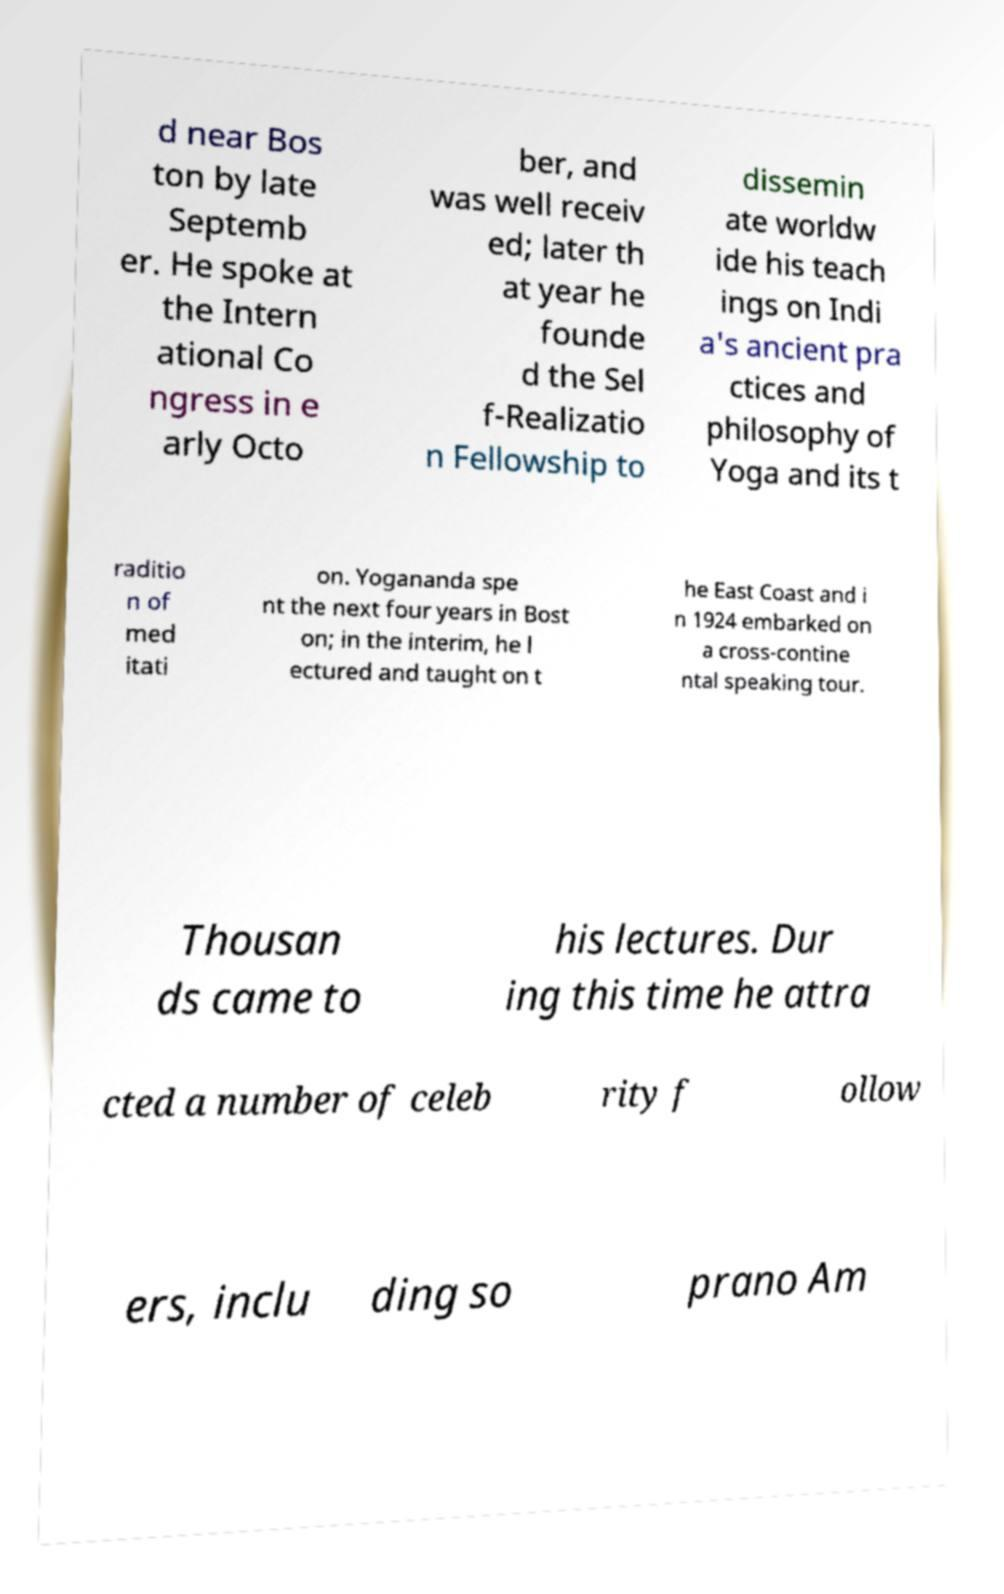There's text embedded in this image that I need extracted. Can you transcribe it verbatim? d near Bos ton by late Septemb er. He spoke at the Intern ational Co ngress in e arly Octo ber, and was well receiv ed; later th at year he founde d the Sel f-Realizatio n Fellowship to dissemin ate worldw ide his teach ings on Indi a's ancient pra ctices and philosophy of Yoga and its t raditio n of med itati on. Yogananda spe nt the next four years in Bost on; in the interim, he l ectured and taught on t he East Coast and i n 1924 embarked on a cross-contine ntal speaking tour. Thousan ds came to his lectures. Dur ing this time he attra cted a number of celeb rity f ollow ers, inclu ding so prano Am 